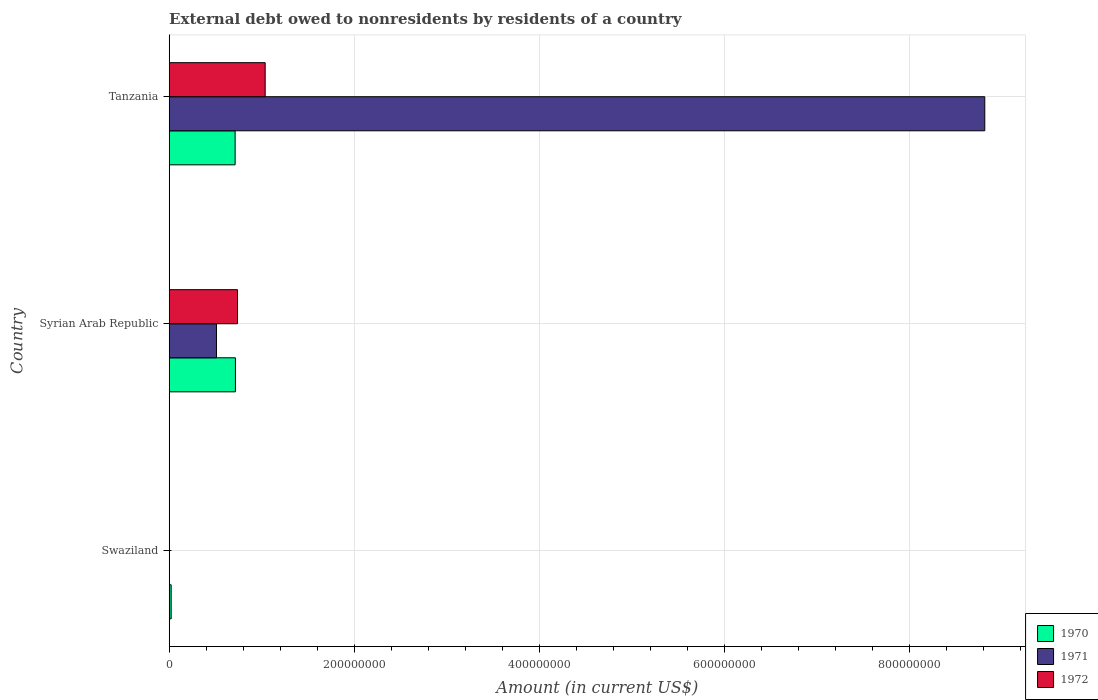How many different coloured bars are there?
Offer a very short reply. 3. Are the number of bars on each tick of the Y-axis equal?
Provide a succinct answer. No. How many bars are there on the 2nd tick from the top?
Keep it short and to the point. 3. How many bars are there on the 1st tick from the bottom?
Your response must be concise. 1. What is the label of the 2nd group of bars from the top?
Keep it short and to the point. Syrian Arab Republic. Across all countries, what is the maximum external debt owed by residents in 1971?
Offer a very short reply. 8.81e+08. Across all countries, what is the minimum external debt owed by residents in 1971?
Make the answer very short. 0. In which country was the external debt owed by residents in 1972 maximum?
Provide a short and direct response. Tanzania. What is the total external debt owed by residents in 1971 in the graph?
Give a very brief answer. 9.33e+08. What is the difference between the external debt owed by residents in 1970 in Swaziland and that in Syrian Arab Republic?
Offer a very short reply. -6.95e+07. What is the difference between the external debt owed by residents in 1971 in Syrian Arab Republic and the external debt owed by residents in 1972 in Swaziland?
Ensure brevity in your answer.  5.11e+07. What is the average external debt owed by residents in 1972 per country?
Your answer should be compact. 5.92e+07. What is the difference between the external debt owed by residents in 1971 and external debt owed by residents in 1972 in Syrian Arab Republic?
Keep it short and to the point. -2.28e+07. What is the ratio of the external debt owed by residents in 1972 in Syrian Arab Republic to that in Tanzania?
Provide a succinct answer. 0.71. Is the difference between the external debt owed by residents in 1971 in Syrian Arab Republic and Tanzania greater than the difference between the external debt owed by residents in 1972 in Syrian Arab Republic and Tanzania?
Make the answer very short. No. What is the difference between the highest and the second highest external debt owed by residents in 1970?
Your answer should be compact. 3.21e+05. What is the difference between the highest and the lowest external debt owed by residents in 1972?
Your answer should be compact. 1.04e+08. How many countries are there in the graph?
Provide a short and direct response. 3. What is the difference between two consecutive major ticks on the X-axis?
Offer a terse response. 2.00e+08. Does the graph contain any zero values?
Offer a terse response. Yes. Does the graph contain grids?
Provide a short and direct response. Yes. How many legend labels are there?
Provide a succinct answer. 3. How are the legend labels stacked?
Offer a very short reply. Vertical. What is the title of the graph?
Give a very brief answer. External debt owed to nonresidents by residents of a country. Does "1961" appear as one of the legend labels in the graph?
Provide a succinct answer. No. What is the label or title of the Y-axis?
Offer a very short reply. Country. What is the Amount (in current US$) in 1970 in Swaziland?
Keep it short and to the point. 2.10e+06. What is the Amount (in current US$) of 1971 in Swaziland?
Provide a short and direct response. 0. What is the Amount (in current US$) of 1972 in Swaziland?
Keep it short and to the point. 0. What is the Amount (in current US$) in 1970 in Syrian Arab Republic?
Offer a very short reply. 7.16e+07. What is the Amount (in current US$) in 1971 in Syrian Arab Republic?
Keep it short and to the point. 5.11e+07. What is the Amount (in current US$) in 1972 in Syrian Arab Republic?
Offer a terse response. 7.38e+07. What is the Amount (in current US$) in 1970 in Tanzania?
Give a very brief answer. 7.13e+07. What is the Amount (in current US$) of 1971 in Tanzania?
Keep it short and to the point. 8.81e+08. What is the Amount (in current US$) in 1972 in Tanzania?
Give a very brief answer. 1.04e+08. Across all countries, what is the maximum Amount (in current US$) in 1970?
Keep it short and to the point. 7.16e+07. Across all countries, what is the maximum Amount (in current US$) in 1971?
Provide a succinct answer. 8.81e+08. Across all countries, what is the maximum Amount (in current US$) of 1972?
Your answer should be compact. 1.04e+08. Across all countries, what is the minimum Amount (in current US$) of 1970?
Your answer should be compact. 2.10e+06. Across all countries, what is the minimum Amount (in current US$) of 1971?
Ensure brevity in your answer.  0. What is the total Amount (in current US$) in 1970 in the graph?
Your answer should be very brief. 1.45e+08. What is the total Amount (in current US$) in 1971 in the graph?
Keep it short and to the point. 9.33e+08. What is the total Amount (in current US$) of 1972 in the graph?
Ensure brevity in your answer.  1.78e+08. What is the difference between the Amount (in current US$) of 1970 in Swaziland and that in Syrian Arab Republic?
Make the answer very short. -6.95e+07. What is the difference between the Amount (in current US$) in 1970 in Swaziland and that in Tanzania?
Offer a terse response. -6.91e+07. What is the difference between the Amount (in current US$) of 1970 in Syrian Arab Republic and that in Tanzania?
Provide a short and direct response. 3.21e+05. What is the difference between the Amount (in current US$) of 1971 in Syrian Arab Republic and that in Tanzania?
Your response must be concise. -8.30e+08. What is the difference between the Amount (in current US$) in 1972 in Syrian Arab Republic and that in Tanzania?
Your response must be concise. -2.99e+07. What is the difference between the Amount (in current US$) of 1970 in Swaziland and the Amount (in current US$) of 1971 in Syrian Arab Republic?
Your answer should be very brief. -4.90e+07. What is the difference between the Amount (in current US$) of 1970 in Swaziland and the Amount (in current US$) of 1972 in Syrian Arab Republic?
Your answer should be very brief. -7.17e+07. What is the difference between the Amount (in current US$) of 1970 in Swaziland and the Amount (in current US$) of 1971 in Tanzania?
Provide a succinct answer. -8.79e+08. What is the difference between the Amount (in current US$) of 1970 in Swaziland and the Amount (in current US$) of 1972 in Tanzania?
Your response must be concise. -1.02e+08. What is the difference between the Amount (in current US$) in 1970 in Syrian Arab Republic and the Amount (in current US$) in 1971 in Tanzania?
Make the answer very short. -8.10e+08. What is the difference between the Amount (in current US$) of 1970 in Syrian Arab Republic and the Amount (in current US$) of 1972 in Tanzania?
Make the answer very short. -3.21e+07. What is the difference between the Amount (in current US$) of 1971 in Syrian Arab Republic and the Amount (in current US$) of 1972 in Tanzania?
Provide a short and direct response. -5.26e+07. What is the average Amount (in current US$) of 1970 per country?
Your response must be concise. 4.83e+07. What is the average Amount (in current US$) of 1971 per country?
Ensure brevity in your answer.  3.11e+08. What is the average Amount (in current US$) in 1972 per country?
Your response must be concise. 5.92e+07. What is the difference between the Amount (in current US$) of 1970 and Amount (in current US$) of 1971 in Syrian Arab Republic?
Give a very brief answer. 2.05e+07. What is the difference between the Amount (in current US$) in 1970 and Amount (in current US$) in 1972 in Syrian Arab Republic?
Ensure brevity in your answer.  -2.27e+06. What is the difference between the Amount (in current US$) in 1971 and Amount (in current US$) in 1972 in Syrian Arab Republic?
Keep it short and to the point. -2.28e+07. What is the difference between the Amount (in current US$) of 1970 and Amount (in current US$) of 1971 in Tanzania?
Provide a short and direct response. -8.10e+08. What is the difference between the Amount (in current US$) of 1970 and Amount (in current US$) of 1972 in Tanzania?
Provide a succinct answer. -3.25e+07. What is the difference between the Amount (in current US$) in 1971 and Amount (in current US$) in 1972 in Tanzania?
Keep it short and to the point. 7.78e+08. What is the ratio of the Amount (in current US$) in 1970 in Swaziland to that in Syrian Arab Republic?
Provide a succinct answer. 0.03. What is the ratio of the Amount (in current US$) of 1970 in Swaziland to that in Tanzania?
Provide a succinct answer. 0.03. What is the ratio of the Amount (in current US$) in 1971 in Syrian Arab Republic to that in Tanzania?
Your response must be concise. 0.06. What is the ratio of the Amount (in current US$) in 1972 in Syrian Arab Republic to that in Tanzania?
Your answer should be compact. 0.71. What is the difference between the highest and the second highest Amount (in current US$) of 1970?
Offer a very short reply. 3.21e+05. What is the difference between the highest and the lowest Amount (in current US$) of 1970?
Your response must be concise. 6.95e+07. What is the difference between the highest and the lowest Amount (in current US$) of 1971?
Offer a very short reply. 8.81e+08. What is the difference between the highest and the lowest Amount (in current US$) of 1972?
Provide a succinct answer. 1.04e+08. 